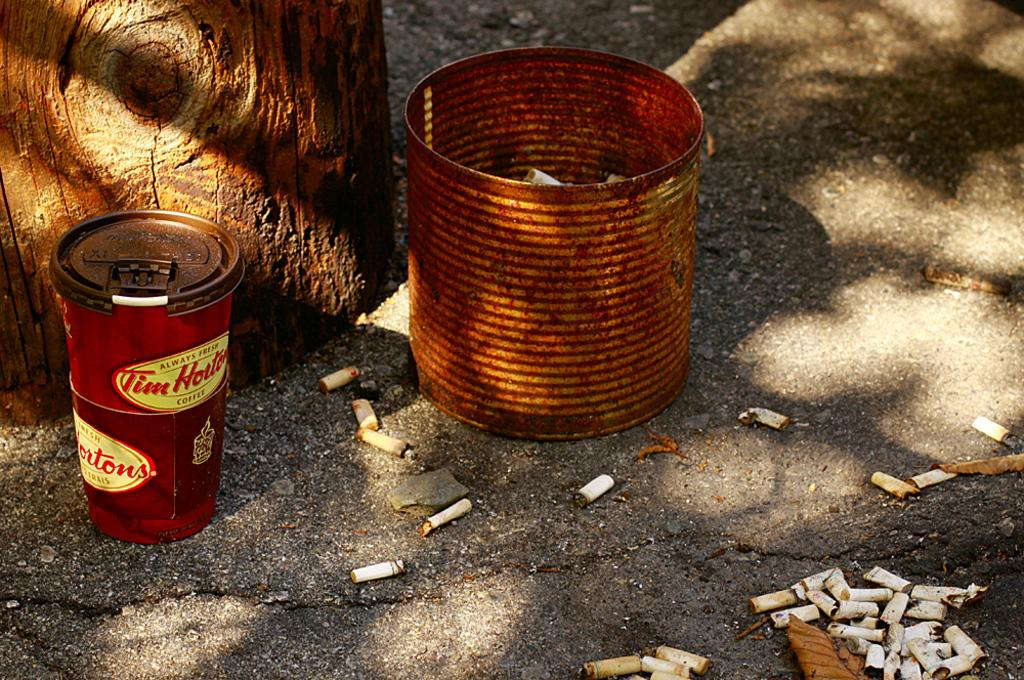Provide a one-sentence caption for the provided image. A LARGE RUSTY TIN CAN FILLED WITH BUTTS AND CAN OF TIM HORTONS. 